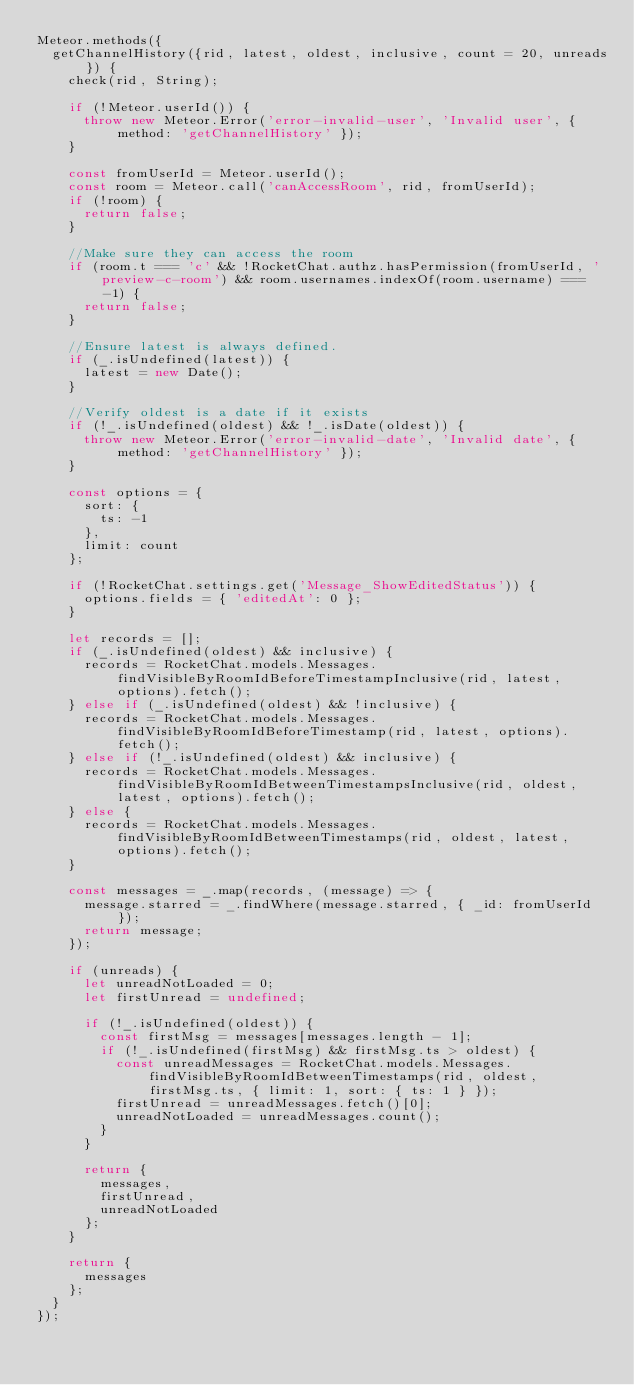Convert code to text. <code><loc_0><loc_0><loc_500><loc_500><_JavaScript_>Meteor.methods({
	getChannelHistory({rid, latest, oldest, inclusive, count = 20, unreads}) {
		check(rid, String);

		if (!Meteor.userId()) {
			throw new Meteor.Error('error-invalid-user', 'Invalid user', { method: 'getChannelHistory' });
		}

		const fromUserId = Meteor.userId();
		const room = Meteor.call('canAccessRoom', rid, fromUserId);
		if (!room) {
			return false;
		}

		//Make sure they can access the room
		if (room.t === 'c' && !RocketChat.authz.hasPermission(fromUserId, 'preview-c-room') && room.usernames.indexOf(room.username) === -1) {
			return false;
		}

		//Ensure latest is always defined.
		if (_.isUndefined(latest)) {
			latest = new Date();
		}

		//Verify oldest is a date if it exists
		if (!_.isUndefined(oldest) && !_.isDate(oldest)) {
			throw new Meteor.Error('error-invalid-date', 'Invalid date', { method: 'getChannelHistory' });
		}

		const options = {
			sort: {
				ts: -1
			},
			limit: count
		};

		if (!RocketChat.settings.get('Message_ShowEditedStatus')) {
			options.fields = { 'editedAt': 0 };
		}

		let records = [];
		if (_.isUndefined(oldest) && inclusive) {
			records = RocketChat.models.Messages.findVisibleByRoomIdBeforeTimestampInclusive(rid, latest, options).fetch();
		} else if (_.isUndefined(oldest) && !inclusive) {
			records = RocketChat.models.Messages.findVisibleByRoomIdBeforeTimestamp(rid, latest, options).fetch();
		} else if (!_.isUndefined(oldest) && inclusive) {
			records = RocketChat.models.Messages.findVisibleByRoomIdBetweenTimestampsInclusive(rid, oldest, latest, options).fetch();
		} else {
			records = RocketChat.models.Messages.findVisibleByRoomIdBetweenTimestamps(rid, oldest, latest, options).fetch();
		}

		const messages = _.map(records, (message) => {
			message.starred = _.findWhere(message.starred, { _id: fromUserId });
			return message;
		});

		if (unreads) {
			let unreadNotLoaded = 0;
			let firstUnread = undefined;

			if (!_.isUndefined(oldest)) {
				const firstMsg = messages[messages.length - 1];
				if (!_.isUndefined(firstMsg) && firstMsg.ts > oldest) {
					const unreadMessages = RocketChat.models.Messages.findVisibleByRoomIdBetweenTimestamps(rid, oldest, firstMsg.ts, { limit: 1, sort: { ts: 1 } });
					firstUnread = unreadMessages.fetch()[0];
					unreadNotLoaded = unreadMessages.count();
				}
			}

			return {
				messages,
				firstUnread,
				unreadNotLoaded
			};
		}

		return {
			messages
		};
	}
});
</code> 